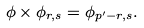<formula> <loc_0><loc_0><loc_500><loc_500>\phi \times \phi _ { r , s } = \phi _ { p ^ { \prime } - r , s } .</formula> 